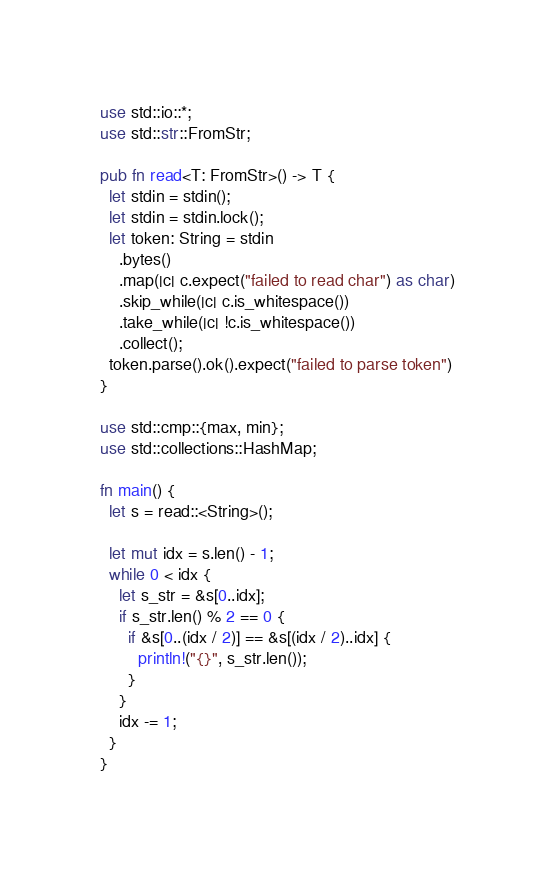Convert code to text. <code><loc_0><loc_0><loc_500><loc_500><_Rust_>
use std::io::*;
use std::str::FromStr;

pub fn read<T: FromStr>() -> T {
  let stdin = stdin();
  let stdin = stdin.lock();
  let token: String = stdin
    .bytes()
    .map(|c| c.expect("failed to read char") as char)
    .skip_while(|c| c.is_whitespace())
    .take_while(|c| !c.is_whitespace())
    .collect();
  token.parse().ok().expect("failed to parse token")
}

use std::cmp::{max, min};
use std::collections::HashMap;

fn main() {
  let s = read::<String>();

  let mut idx = s.len() - 1;
  while 0 < idx {
    let s_str = &s[0..idx];
    if s_str.len() % 2 == 0 {
      if &s[0..(idx / 2)] == &s[(idx / 2)..idx] {
        println!("{}", s_str.len());
      }
    }
    idx -= 1;
  }
}
</code> 